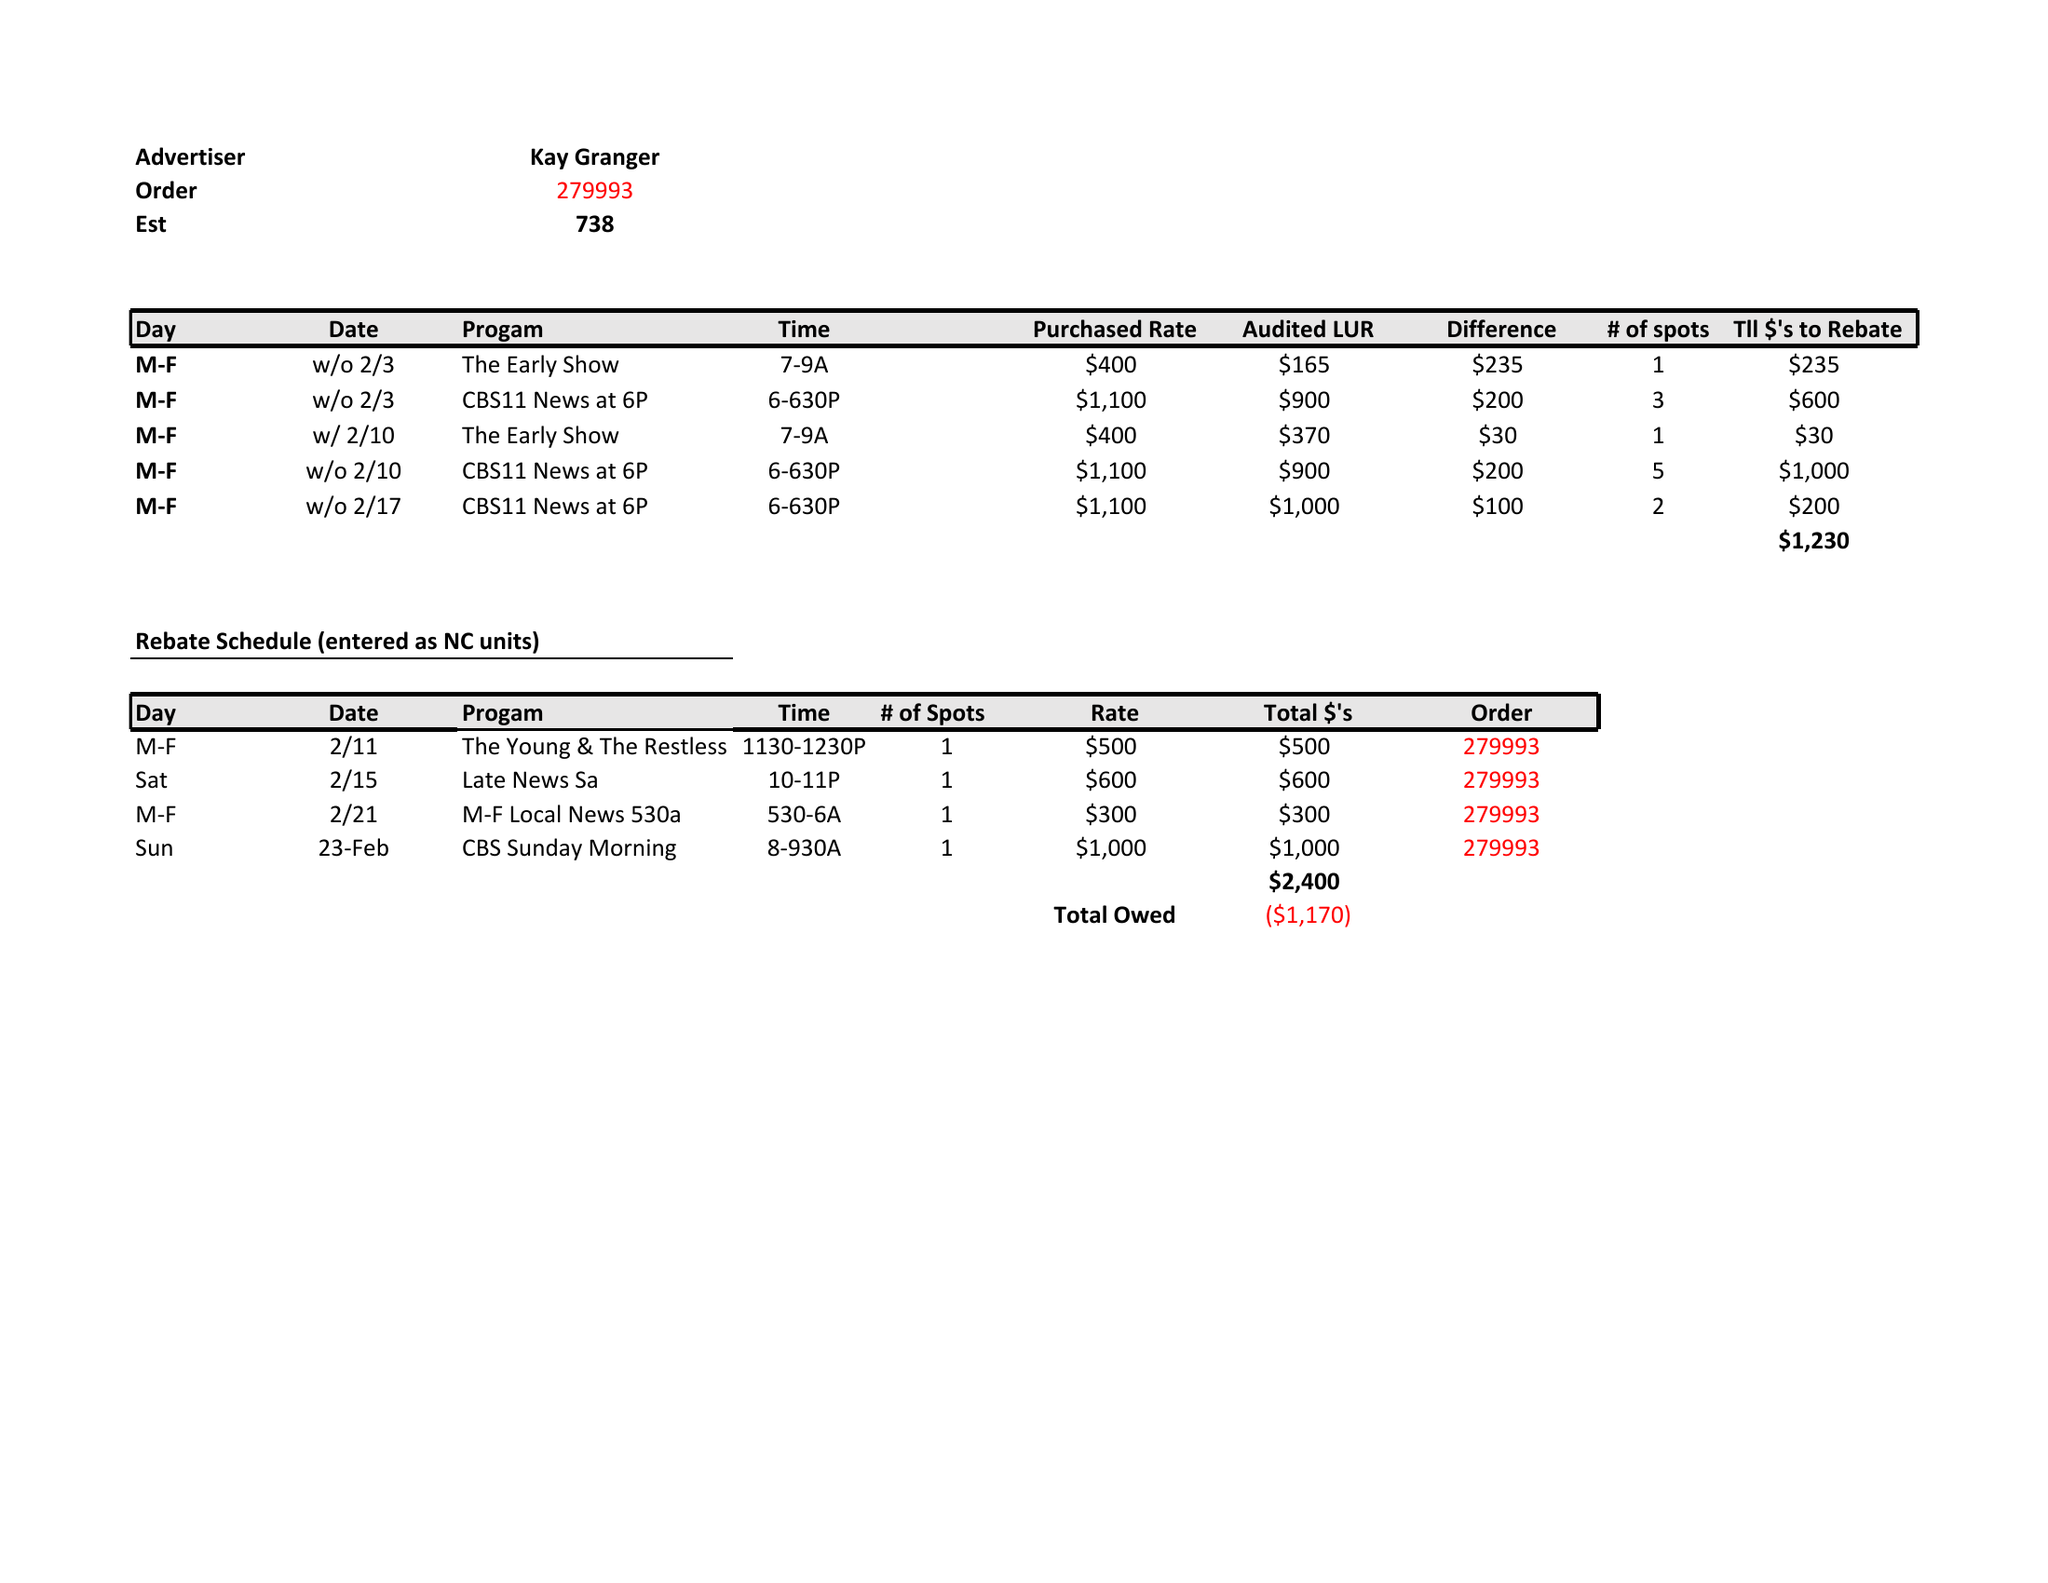What is the value for the contract_num?
Answer the question using a single word or phrase. 273993 